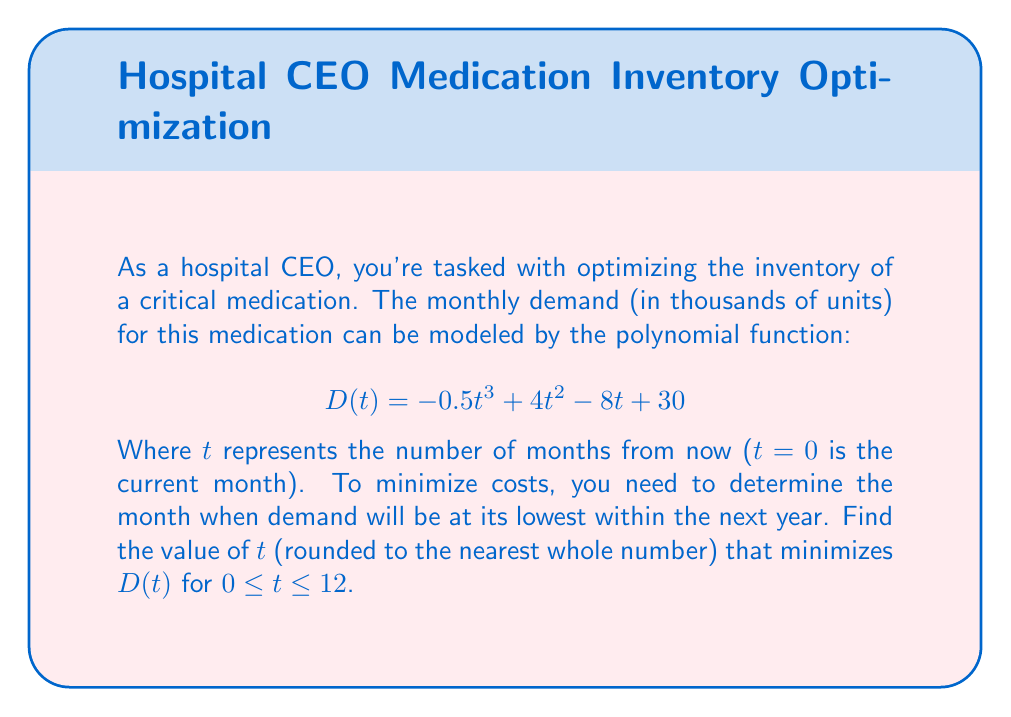Give your solution to this math problem. To find the minimum value of $D(t)$ within the given interval, we need to follow these steps:

1) First, we find the derivative of $D(t)$:
   $$D'(t) = -1.5t^2 + 8t - 8$$

2) Set $D'(t) = 0$ to find potential critical points:
   $$-1.5t^2 + 8t - 8 = 0$$

3) Solve this quadratic equation:
   $$t = \frac{-8 \pm \sqrt{64 + 48}}{-3} = \frac{-8 \pm \sqrt{112}}{-3}$$

4) Simplify:
   $$t_1 = \frac{-8 + 2\sqrt{28}}{-3} \approx 0.84$$
   $$t_2 = \frac{-8 - 2\sqrt{28}}{-3} \approx 4.49$$

5) Since we're looking for $t$ within $[0, 12]$, both these critical points are relevant.

6) We also need to check the endpoints of our interval (0 and 12).

7) Evaluate $D(t)$ at $t = 0$, $t \approx 0.84$, $t \approx 4.49$, and $t = 12$:
   $$D(0) = 30$$
   $$D(0.84) \approx 26.76$$
   $$D(4.49) \approx 20.01$$
   $$D(12) \approx 654$$

8) The minimum occurs at $t \approx 4.49$.

9) Rounding to the nearest whole number gives us 4.
Answer: 4 